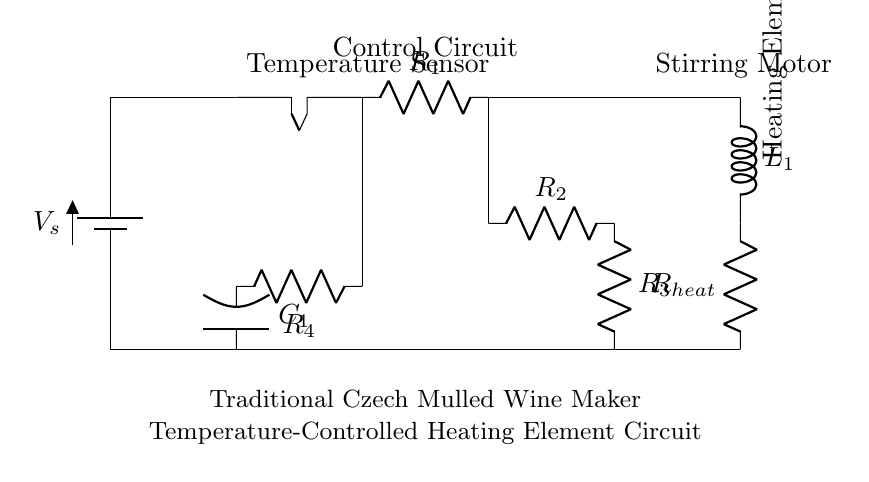What is the main heating element of the circuit? The heating element is indicated as "Heating Element" in the circuit, connected to the control components and powered by the source.
Answer: Heating Element What type of sensor is used in the circuit? The circuit contains a "Temperature Sensor" which measures the temperature for controlling the heating process.
Answer: Temperature Sensor How many resistors are in the circuit? There are four resistors labeled as R1, R2, R3, and R4 in the circuit diagram, contributing to the overall resistance and voltage drop.
Answer: Four What is the function of the motor? The motor is labeled as "Stirring Motor" in the circuit, indicating its role is to stir the mulled wine for consistent temperature distribution.
Answer: Stirring Motor What component is directly responsible for heating? The component responsible for heating is the "Heating Element," which converts electrical energy into heat to warm the mulled wine.
Answer: Heating Element Which component provides the electrical energy for the circuit? The "Battery" labeled as V_s serves as the power source that supplies electrical energy to the entire circuit.
Answer: Battery Why are there multiple resistors connected in the circuit? Multiple resistors, such as R2 and R3, are included for current limiting and stabilizing the circuit, controlling the amount of heat generated for safety and efficiency.
Answer: Current limiting and stabilizing 